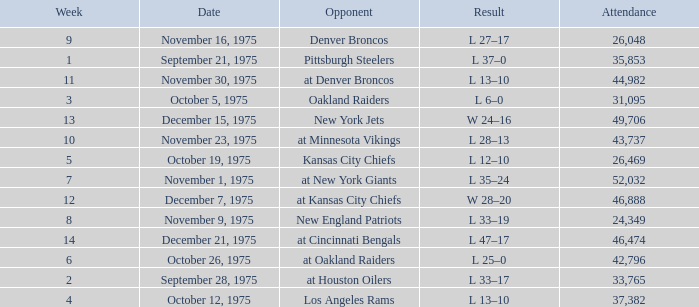What is the lowest Week when the result was l 13–10, November 30, 1975, with more than 44,982 people in attendance? None. 